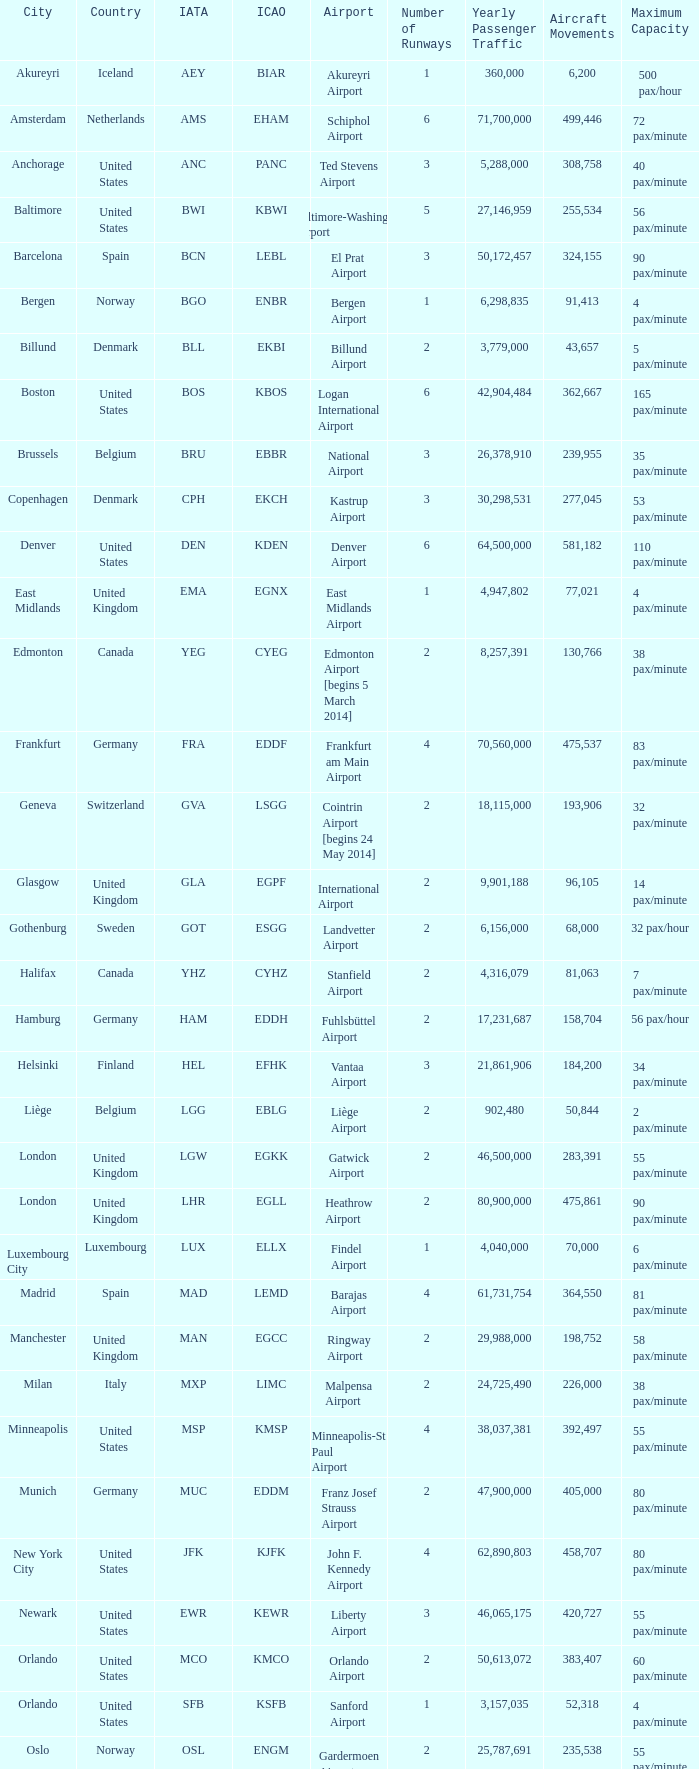What is the IATA OF Akureyri? AEY. 